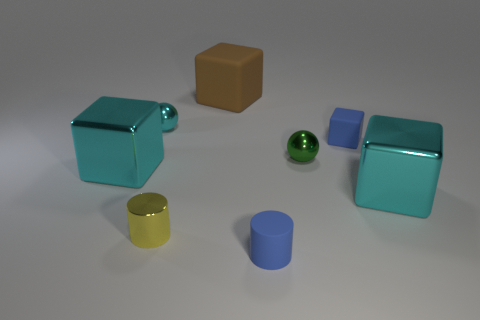The big cyan thing on the right side of the small green metallic ball has what shape?
Offer a very short reply. Cube. Do the green shiny thing and the cyan cube that is to the left of the green shiny thing have the same size?
Ensure brevity in your answer.  No. Is there a tiny thing that has the same material as the small green sphere?
Offer a terse response. Yes. How many spheres are big cyan metal things or small things?
Your response must be concise. 2. Is there a brown rubber thing to the left of the big cyan cube to the left of the tiny blue rubber block?
Provide a succinct answer. No. Are there fewer small yellow cylinders than large rubber balls?
Give a very brief answer. No. What number of small cyan metal things are the same shape as the green object?
Provide a succinct answer. 1. How many red objects are cylinders or large matte spheres?
Your answer should be very brief. 0. What is the size of the ball behind the tiny ball that is on the right side of the brown thing?
Provide a short and direct response. Small. There is a blue object that is the same shape as the yellow metal object; what is its material?
Make the answer very short. Rubber. 